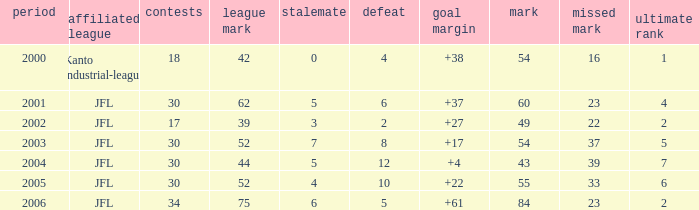Tell me the average final rank for loe more than 10 and point less than 43 None. 